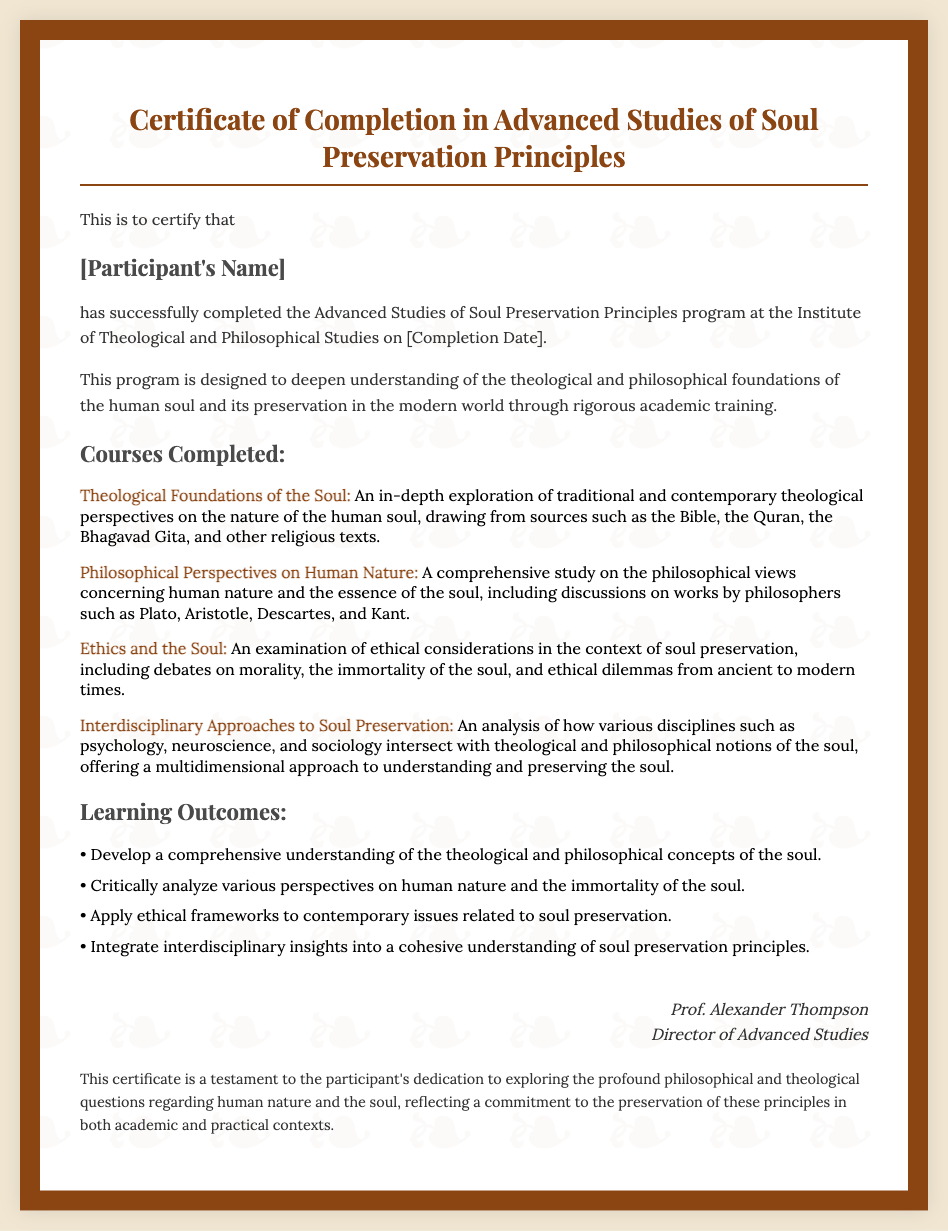What is the title of the certificate? The title of the certificate is presented prominently at the top, indicating what the certificate is for.
Answer: Certificate of Completion in Advanced Studies of Soul Preservation Principles Who is the certificate awarded to? The recipient's name is highlighted in a separate section of the document, indicated by a dedicated heading.
Answer: [Participant's Name] What date is mentioned on the certificate? The completion date is specified in the body text, indicating when the program was finished.
Answer: [Completion Date] Who is the Director of Advanced Studies? The name of the individual who signed the certificate is included at the bottom, along with their title.
Answer: Prof. Alexander Thompson What is the first course listed? The first course mentioned in the document outlines a specific area of study within the program.
Answer: Theological Foundations of the Soul How many learning outcomes are listed? The number of outcomes can be confirmed by counting the bullet points under the learning outcomes section.
Answer: Four What is the main focus of the program? The primary objective of the program is described in a single sentence within the introductory paragraph, summarizing its educational goal.
Answer: To deepen understanding of the theological and philosophical foundations of the human soul What ethical considerations are examined in the program? The document mentions a specific course dedicated to exploring ethical aspects, referencing its relevance to the soul.
Answer: Ethics and the Soul What additional context does the document provide about the participant's dedication? The concluding note describes the participant's commitment to a particular area of study, emphasizing its significance.
Answer: Exploring the profound philosophical and theological questions regarding human nature and the soul 